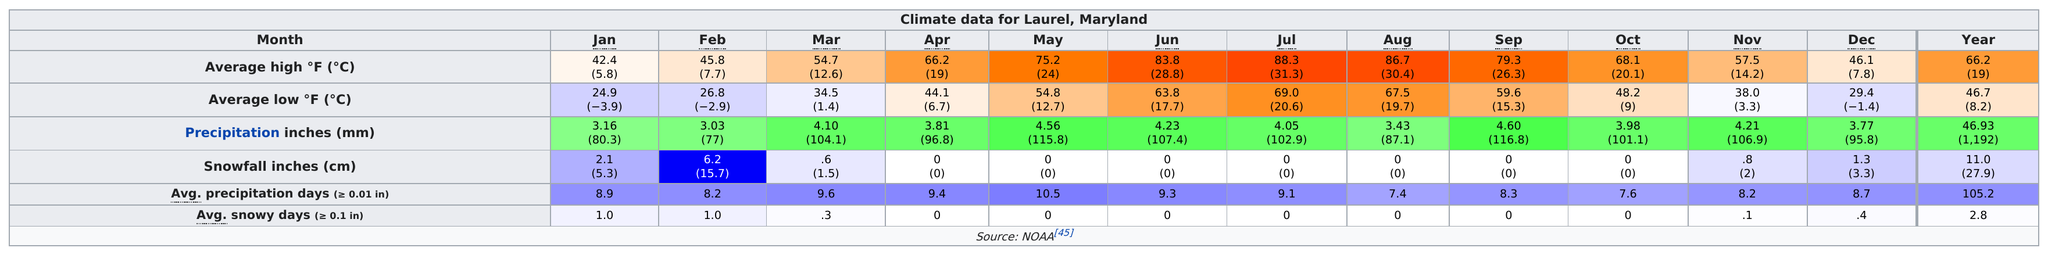Highlight a few significant elements in this photo. There were three months in the year that had an average high temperature in the range of 80 degrees Fahrenheit. February was the month that experienced the greatest accumulation of snowfall. Out of all the months, how many have a total precipitation of less than one? 